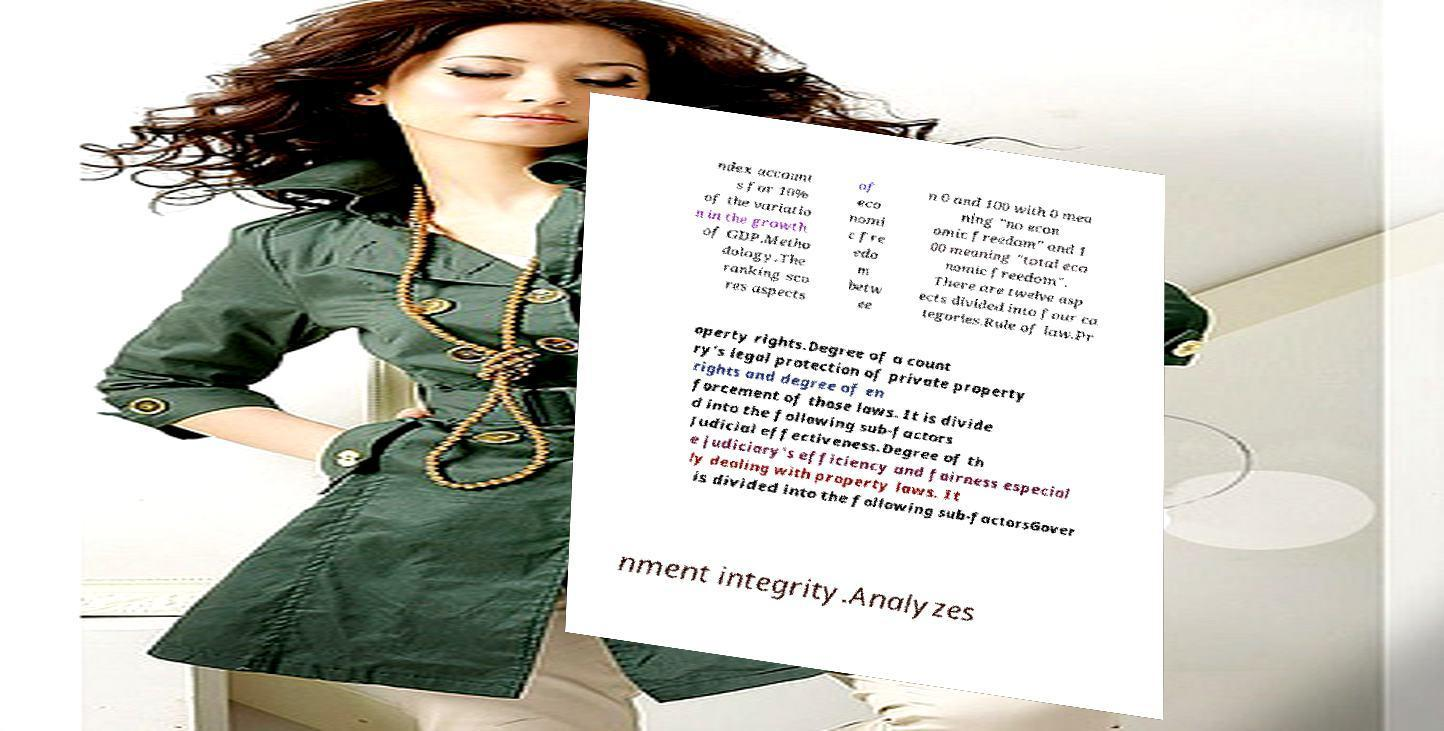I need the written content from this picture converted into text. Can you do that? ndex account s for 10% of the variatio n in the growth of GDP.Metho dology.The ranking sco res aspects of eco nomi c fre edo m betw ee n 0 and 100 with 0 mea ning "no econ omic freedom" and 1 00 meaning "total eco nomic freedom". There are twelve asp ects divided into four ca tegories.Rule of law.Pr operty rights.Degree of a count ry's legal protection of private property rights and degree of en forcement of those laws. It is divide d into the following sub-factors Judicial effectiveness.Degree of th e judiciary's efficiency and fairness especial ly dealing with property laws. It is divided into the following sub-factorsGover nment integrity.Analyzes 